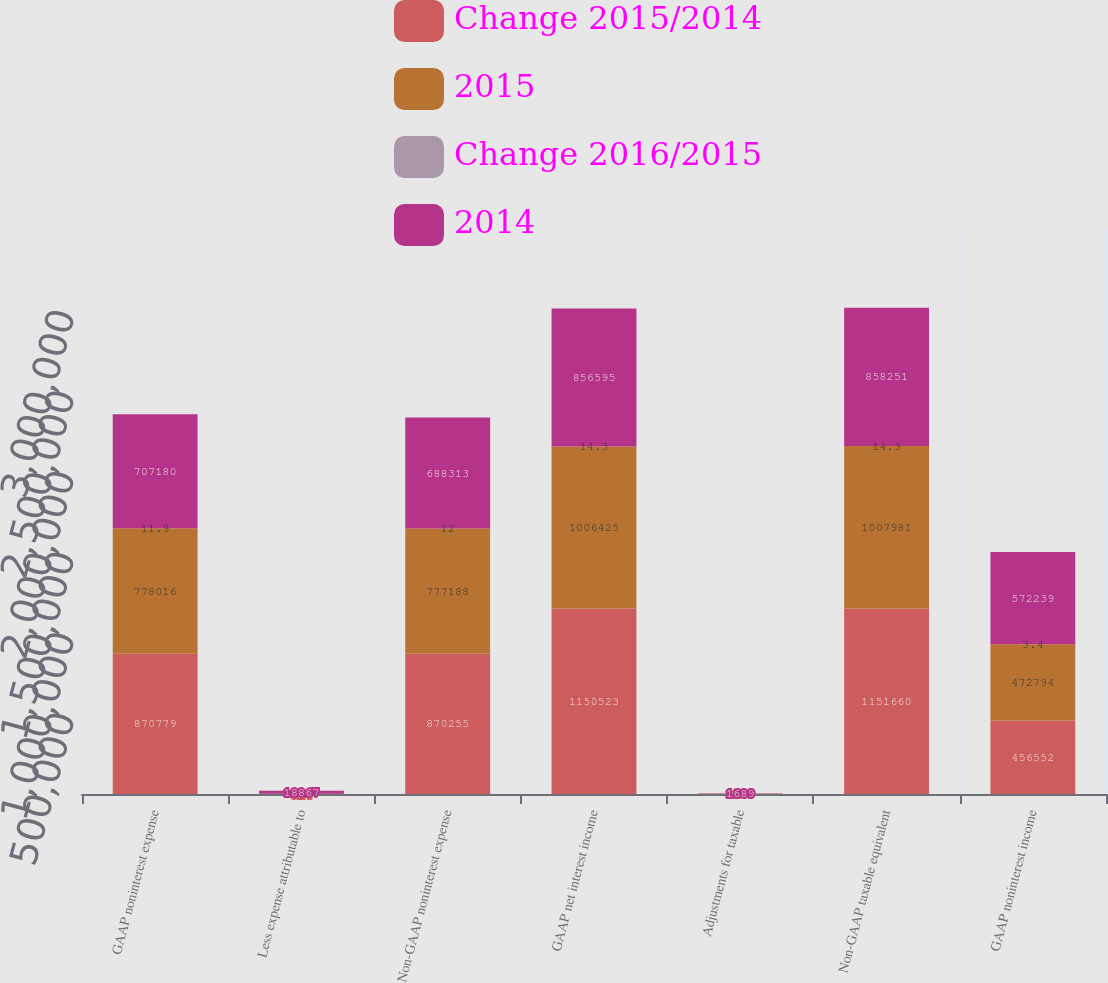Convert chart to OTSL. <chart><loc_0><loc_0><loc_500><loc_500><stacked_bar_chart><ecel><fcel>GAAP noninterest expense<fcel>Less expense attributable to<fcel>Non-GAAP noninterest expense<fcel>GAAP net interest income<fcel>Adjustments for taxable<fcel>Non-GAAP taxable equivalent<fcel>GAAP noninterest income<nl><fcel>Change 2015/2014<fcel>870779<fcel>524<fcel>870255<fcel>1.15052e+06<fcel>1203<fcel>1.15166e+06<fcel>456552<nl><fcel>2015<fcel>778016<fcel>828<fcel>777188<fcel>1.00642e+06<fcel>1564<fcel>1.00798e+06<fcel>472794<nl><fcel>Change 2016/2015<fcel>11.9<fcel>36.7<fcel>12<fcel>14.3<fcel>23.1<fcel>14.3<fcel>3.4<nl><fcel>2014<fcel>707180<fcel>18867<fcel>688313<fcel>856595<fcel>1689<fcel>858251<fcel>572239<nl></chart> 